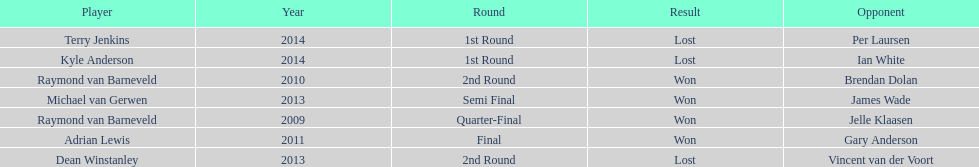Is dean winstanley listed above or below kyle anderson? Above. Can you parse all the data within this table? {'header': ['Player', 'Year', 'Round', 'Result', 'Opponent'], 'rows': [['Terry Jenkins', '2014', '1st Round', 'Lost', 'Per Laursen'], ['Kyle Anderson', '2014', '1st Round', 'Lost', 'Ian White'], ['Raymond van Barneveld', '2010', '2nd Round', 'Won', 'Brendan Dolan'], ['Michael van Gerwen', '2013', 'Semi Final', 'Won', 'James Wade'], ['Raymond van Barneveld', '2009', 'Quarter-Final', 'Won', 'Jelle Klaasen'], ['Adrian Lewis', '2011', 'Final', 'Won', 'Gary Anderson'], ['Dean Winstanley', '2013', '2nd Round', 'Lost', 'Vincent van der Voort']]} 